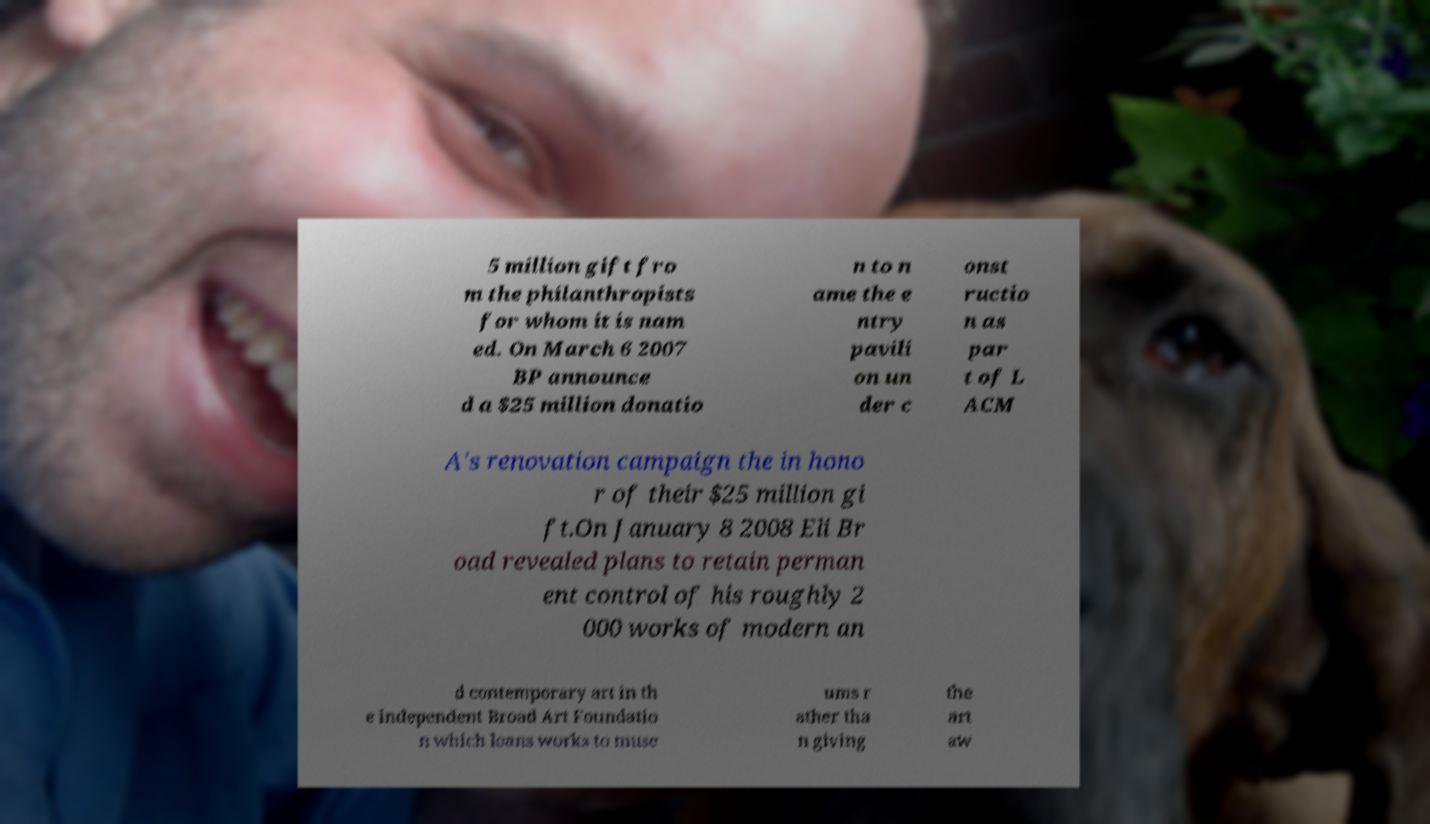Please identify and transcribe the text found in this image. 5 million gift fro m the philanthropists for whom it is nam ed. On March 6 2007 BP announce d a $25 million donatio n to n ame the e ntry pavili on un der c onst ructio n as par t of L ACM A's renovation campaign the in hono r of their $25 million gi ft.On January 8 2008 Eli Br oad revealed plans to retain perman ent control of his roughly 2 000 works of modern an d contemporary art in th e independent Broad Art Foundatio n which loans works to muse ums r ather tha n giving the art aw 